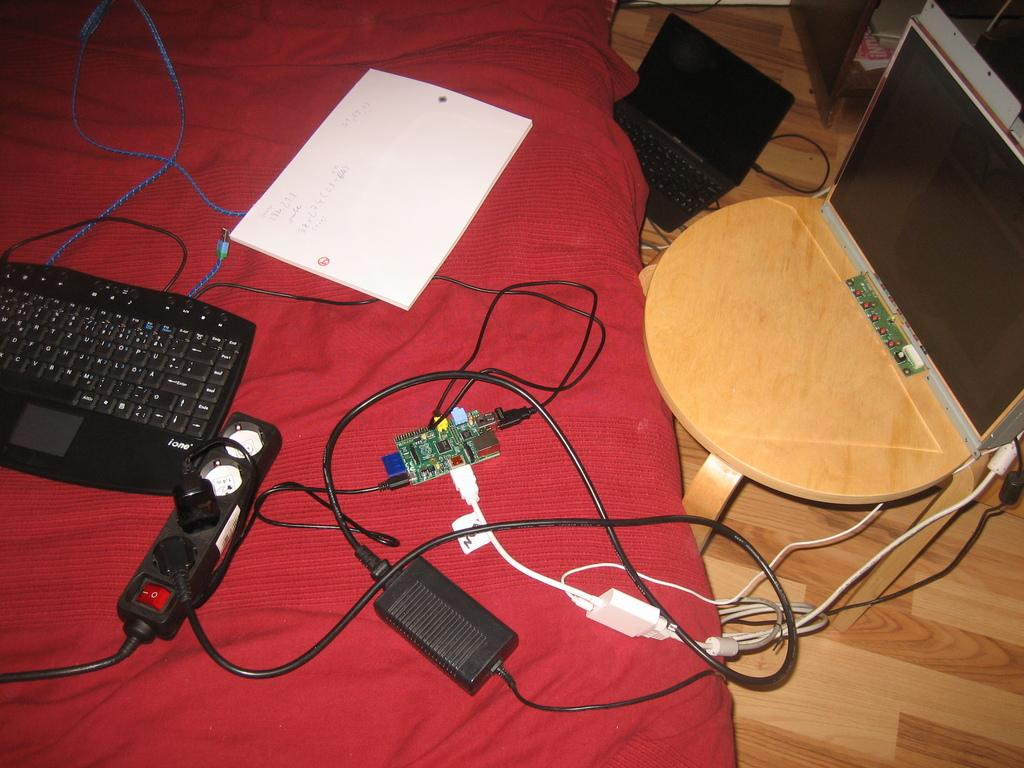What electronic device is visible in the image? There is a keyboard in the image. What other electronic component can be seen in the image? There is a socket board in the image. What type of paper is present in the image? There is a paper in the image. What small electronic component is visible in the image? There is an integrated circuit in the image. On what surface are the objects placed? The objects are placed on a cloth. What piece of furniture is the monitor placed on? There is a monitor on a stool in the image. Where is the laptop located in the image? There is a laptop on the floor in the image. What type of underwear is visible in the image? There is no underwear present in the image. What role does the mother play in the image? There is no mention of a mother or any person in the image. 